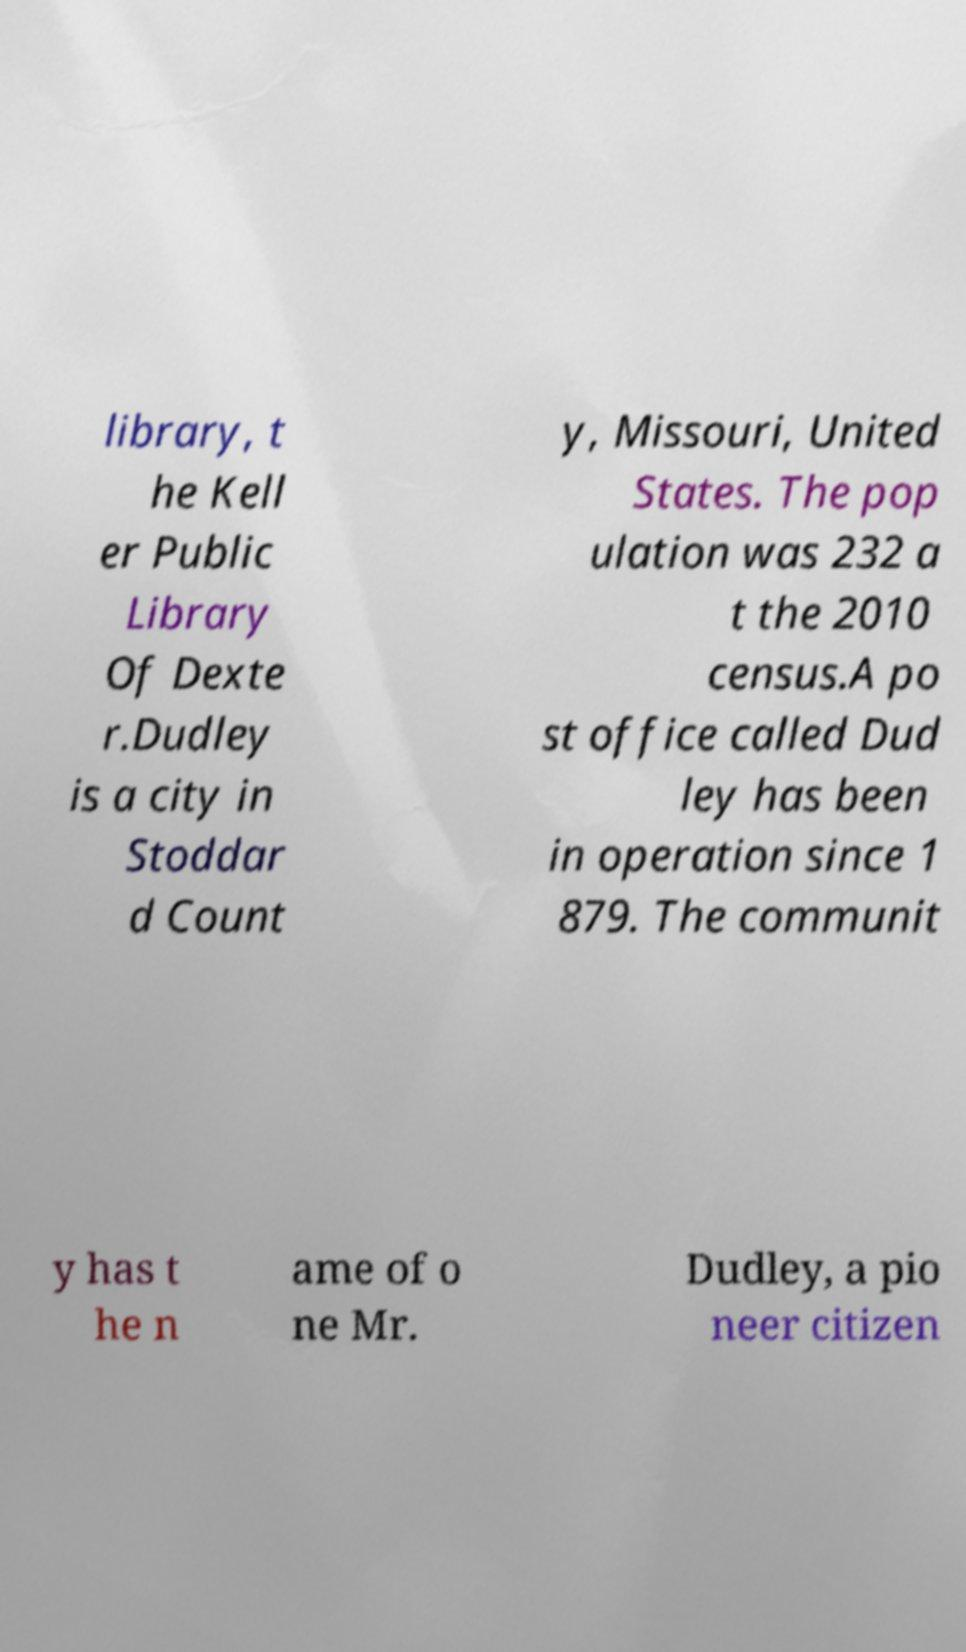There's text embedded in this image that I need extracted. Can you transcribe it verbatim? library, t he Kell er Public Library Of Dexte r.Dudley is a city in Stoddar d Count y, Missouri, United States. The pop ulation was 232 a t the 2010 census.A po st office called Dud ley has been in operation since 1 879. The communit y has t he n ame of o ne Mr. Dudley, a pio neer citizen 